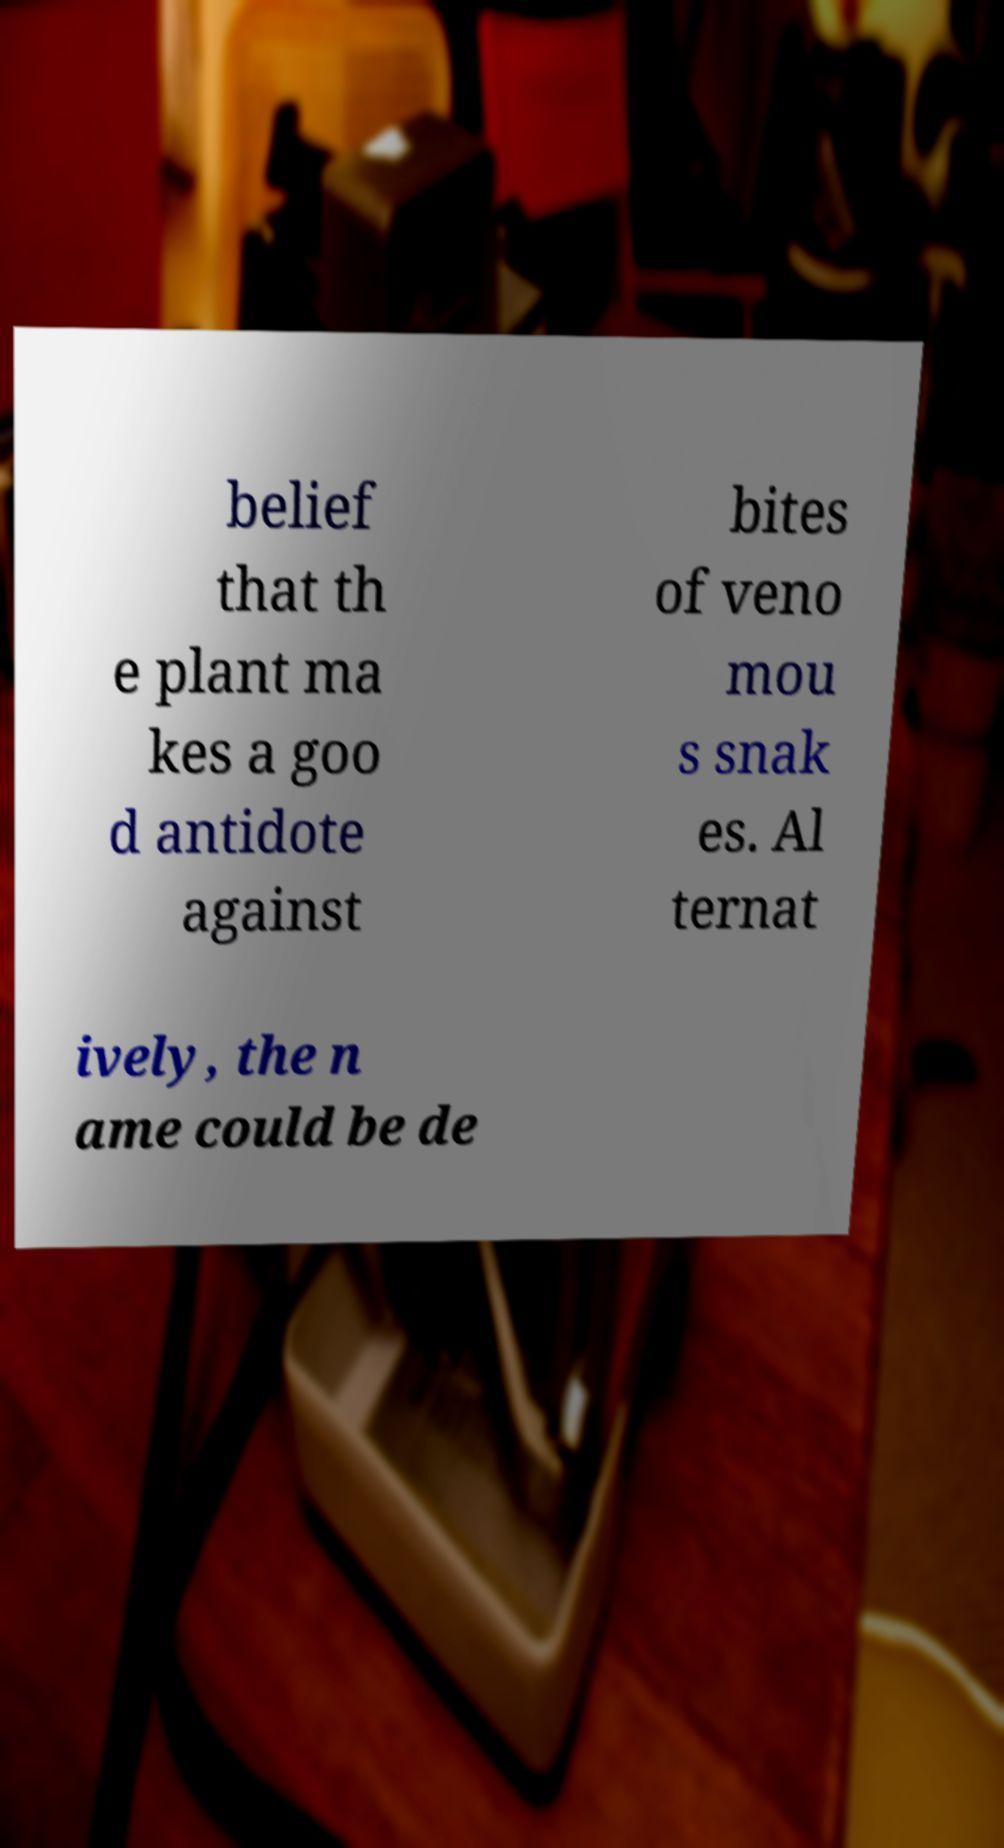I need the written content from this picture converted into text. Can you do that? belief that th e plant ma kes a goo d antidote against bites of veno mou s snak es. Al ternat ively, the n ame could be de 